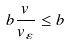<formula> <loc_0><loc_0><loc_500><loc_500>b \frac { v } { v _ { \varepsilon } } \leq b</formula> 